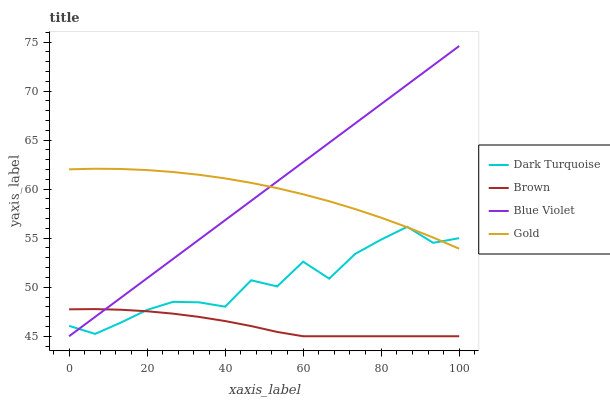Does Brown have the minimum area under the curve?
Answer yes or no. Yes. Does Blue Violet have the maximum area under the curve?
Answer yes or no. Yes. Does Gold have the minimum area under the curve?
Answer yes or no. No. Does Gold have the maximum area under the curve?
Answer yes or no. No. Is Blue Violet the smoothest?
Answer yes or no. Yes. Is Dark Turquoise the roughest?
Answer yes or no. Yes. Is Gold the smoothest?
Answer yes or no. No. Is Gold the roughest?
Answer yes or no. No. Does Blue Violet have the lowest value?
Answer yes or no. Yes. Does Gold have the lowest value?
Answer yes or no. No. Does Blue Violet have the highest value?
Answer yes or no. Yes. Does Gold have the highest value?
Answer yes or no. No. Is Brown less than Gold?
Answer yes or no. Yes. Is Gold greater than Brown?
Answer yes or no. Yes. Does Blue Violet intersect Brown?
Answer yes or no. Yes. Is Blue Violet less than Brown?
Answer yes or no. No. Is Blue Violet greater than Brown?
Answer yes or no. No. Does Brown intersect Gold?
Answer yes or no. No. 